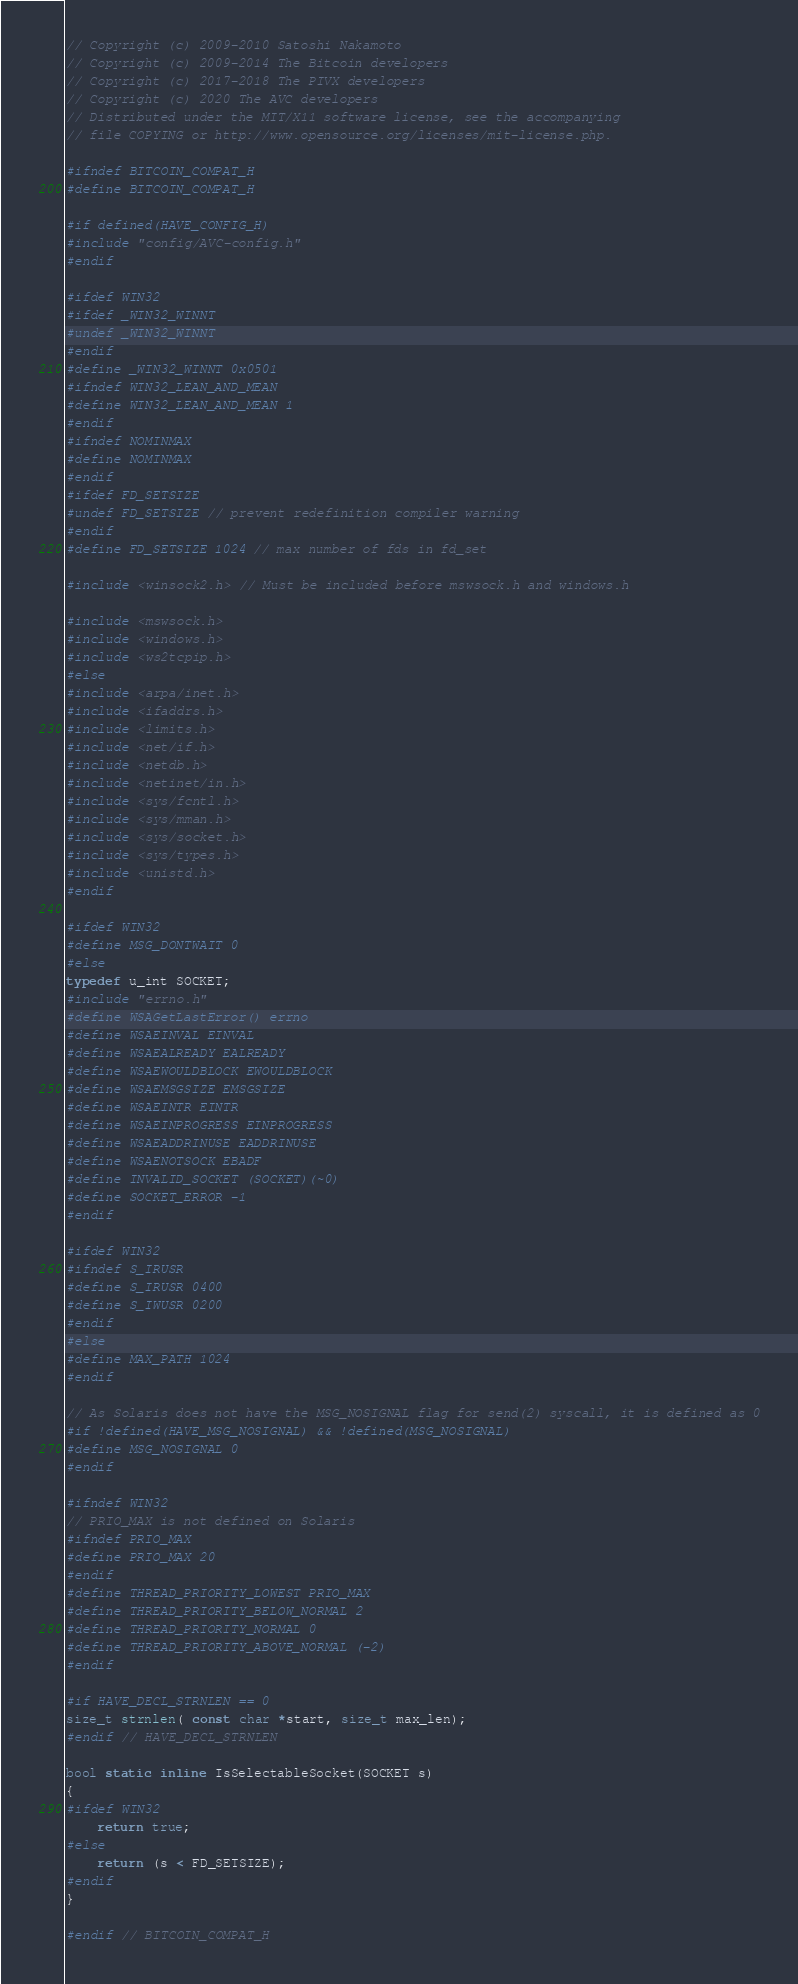Convert code to text. <code><loc_0><loc_0><loc_500><loc_500><_C_>// Copyright (c) 2009-2010 Satoshi Nakamoto
// Copyright (c) 2009-2014 The Bitcoin developers
// Copyright (c) 2017-2018 The PIVX developers
// Copyright (c) 2020 The AVC developers
// Distributed under the MIT/X11 software license, see the accompanying
// file COPYING or http://www.opensource.org/licenses/mit-license.php.

#ifndef BITCOIN_COMPAT_H
#define BITCOIN_COMPAT_H

#if defined(HAVE_CONFIG_H)
#include "config/AVC-config.h"
#endif

#ifdef WIN32
#ifdef _WIN32_WINNT
#undef _WIN32_WINNT
#endif
#define _WIN32_WINNT 0x0501
#ifndef WIN32_LEAN_AND_MEAN
#define WIN32_LEAN_AND_MEAN 1
#endif
#ifndef NOMINMAX
#define NOMINMAX
#endif
#ifdef FD_SETSIZE
#undef FD_SETSIZE // prevent redefinition compiler warning
#endif
#define FD_SETSIZE 1024 // max number of fds in fd_set

#include <winsock2.h> // Must be included before mswsock.h and windows.h

#include <mswsock.h>
#include <windows.h>
#include <ws2tcpip.h>
#else
#include <arpa/inet.h>
#include <ifaddrs.h>
#include <limits.h>
#include <net/if.h>
#include <netdb.h>
#include <netinet/in.h>
#include <sys/fcntl.h>
#include <sys/mman.h>
#include <sys/socket.h>
#include <sys/types.h>
#include <unistd.h>
#endif

#ifdef WIN32
#define MSG_DONTWAIT 0
#else
typedef u_int SOCKET;
#include "errno.h"
#define WSAGetLastError() errno
#define WSAEINVAL EINVAL
#define WSAEALREADY EALREADY
#define WSAEWOULDBLOCK EWOULDBLOCK
#define WSAEMSGSIZE EMSGSIZE
#define WSAEINTR EINTR
#define WSAEINPROGRESS EINPROGRESS
#define WSAEADDRINUSE EADDRINUSE
#define WSAENOTSOCK EBADF
#define INVALID_SOCKET (SOCKET)(~0)
#define SOCKET_ERROR -1
#endif

#ifdef WIN32
#ifndef S_IRUSR
#define S_IRUSR 0400
#define S_IWUSR 0200
#endif
#else
#define MAX_PATH 1024
#endif

// As Solaris does not have the MSG_NOSIGNAL flag for send(2) syscall, it is defined as 0
#if !defined(HAVE_MSG_NOSIGNAL) && !defined(MSG_NOSIGNAL)
#define MSG_NOSIGNAL 0
#endif

#ifndef WIN32
// PRIO_MAX is not defined on Solaris
#ifndef PRIO_MAX
#define PRIO_MAX 20
#endif
#define THREAD_PRIORITY_LOWEST PRIO_MAX
#define THREAD_PRIORITY_BELOW_NORMAL 2
#define THREAD_PRIORITY_NORMAL 0
#define THREAD_PRIORITY_ABOVE_NORMAL (-2)
#endif

#if HAVE_DECL_STRNLEN == 0
size_t strnlen( const char *start, size_t max_len);
#endif // HAVE_DECL_STRNLEN

bool static inline IsSelectableSocket(SOCKET s)
{
#ifdef WIN32
    return true;
#else
    return (s < FD_SETSIZE);
#endif
}

#endif // BITCOIN_COMPAT_H
</code> 